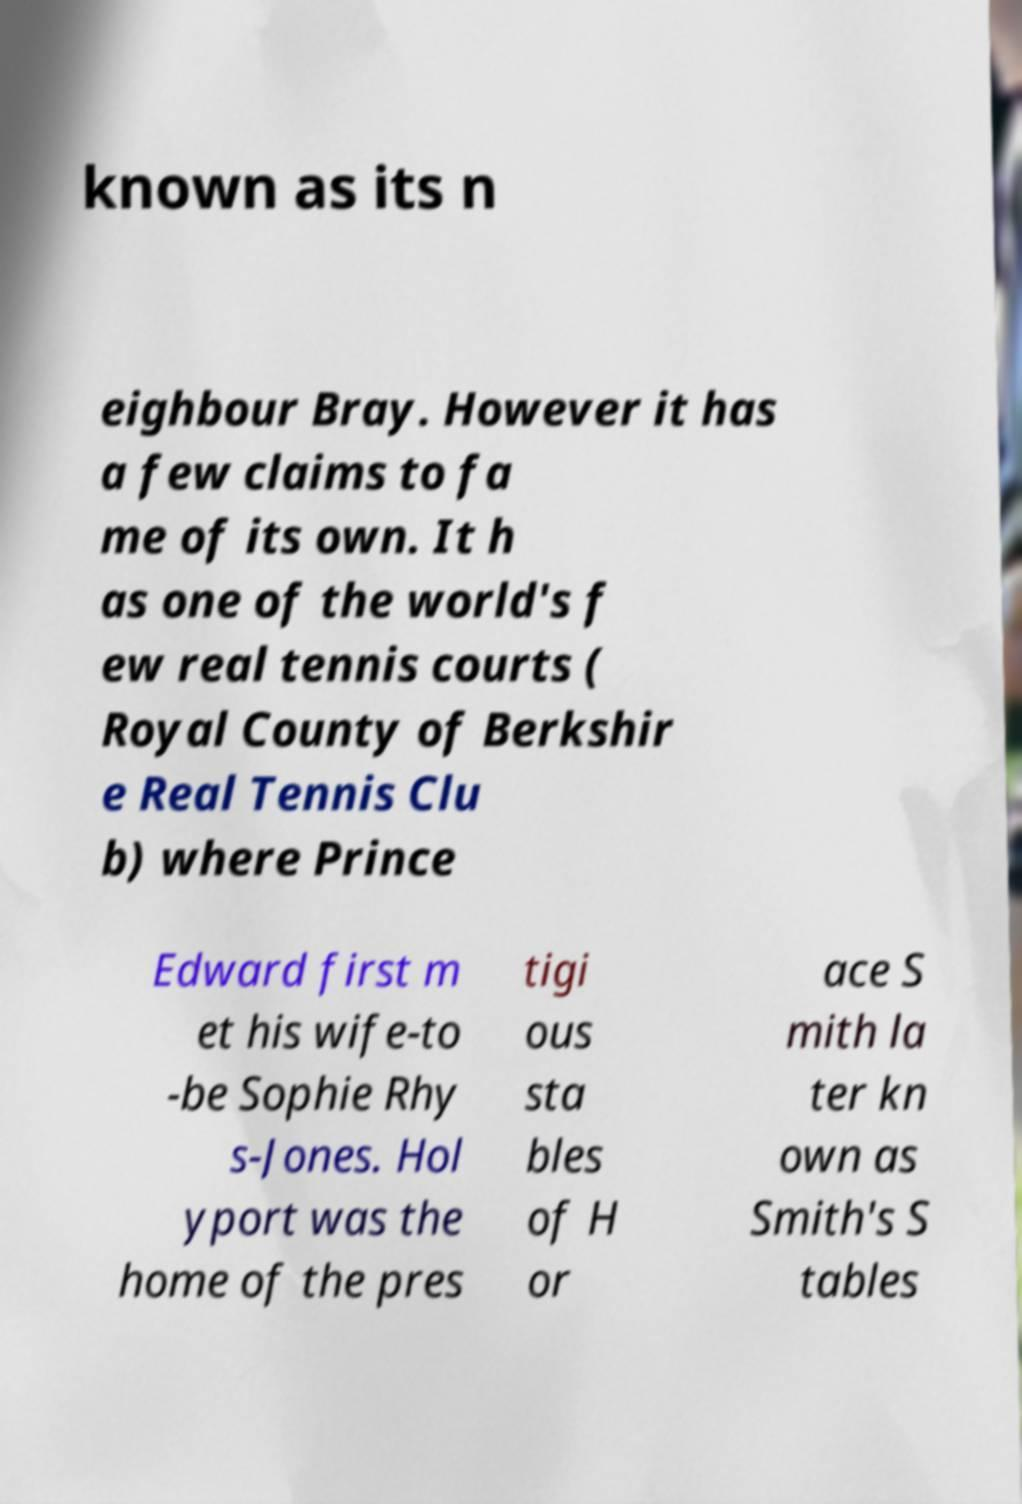Could you extract and type out the text from this image? known as its n eighbour Bray. However it has a few claims to fa me of its own. It h as one of the world's f ew real tennis courts ( Royal County of Berkshir e Real Tennis Clu b) where Prince Edward first m et his wife-to -be Sophie Rhy s-Jones. Hol yport was the home of the pres tigi ous sta bles of H or ace S mith la ter kn own as Smith's S tables 